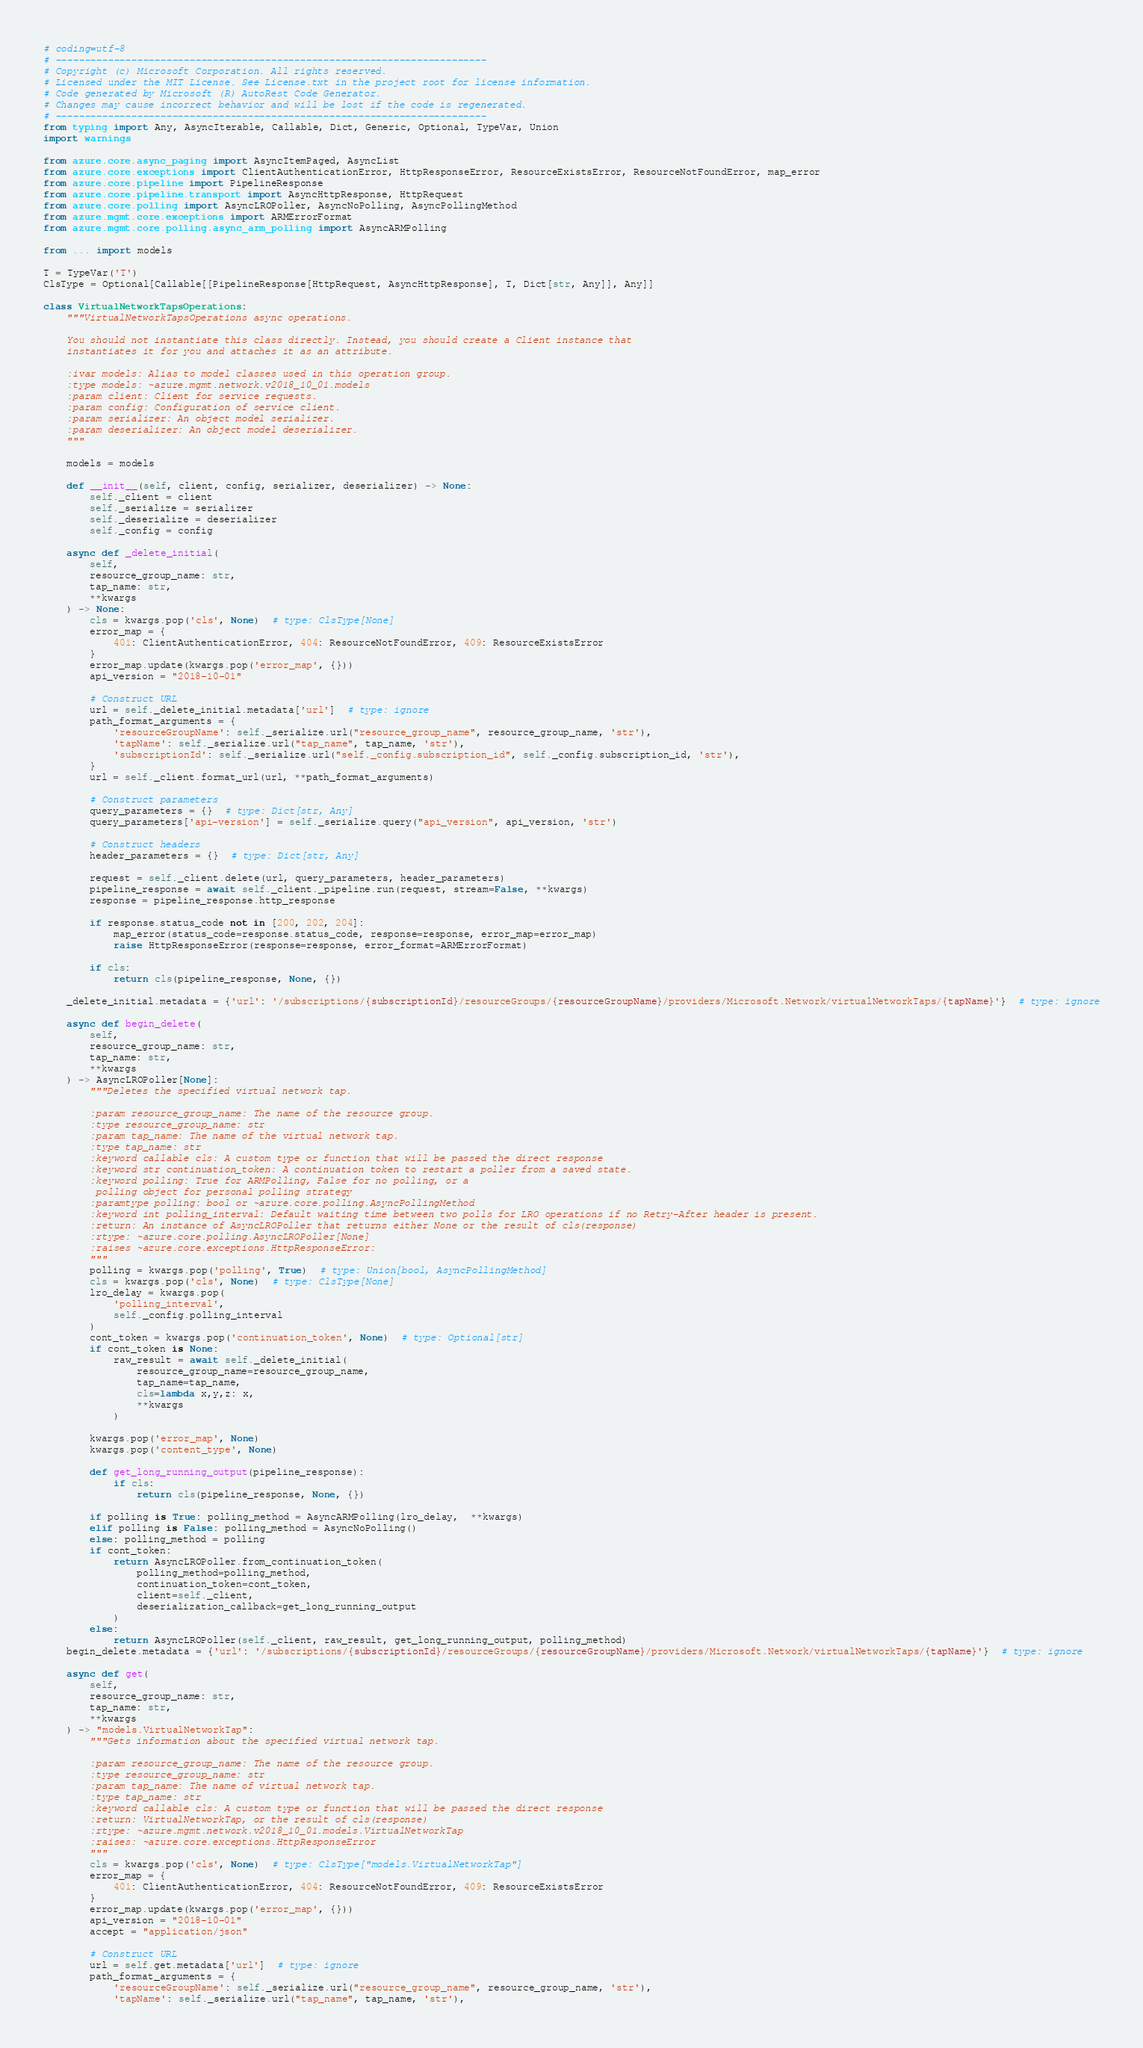Convert code to text. <code><loc_0><loc_0><loc_500><loc_500><_Python_># coding=utf-8
# --------------------------------------------------------------------------
# Copyright (c) Microsoft Corporation. All rights reserved.
# Licensed under the MIT License. See License.txt in the project root for license information.
# Code generated by Microsoft (R) AutoRest Code Generator.
# Changes may cause incorrect behavior and will be lost if the code is regenerated.
# --------------------------------------------------------------------------
from typing import Any, AsyncIterable, Callable, Dict, Generic, Optional, TypeVar, Union
import warnings

from azure.core.async_paging import AsyncItemPaged, AsyncList
from azure.core.exceptions import ClientAuthenticationError, HttpResponseError, ResourceExistsError, ResourceNotFoundError, map_error
from azure.core.pipeline import PipelineResponse
from azure.core.pipeline.transport import AsyncHttpResponse, HttpRequest
from azure.core.polling import AsyncLROPoller, AsyncNoPolling, AsyncPollingMethod
from azure.mgmt.core.exceptions import ARMErrorFormat
from azure.mgmt.core.polling.async_arm_polling import AsyncARMPolling

from ... import models

T = TypeVar('T')
ClsType = Optional[Callable[[PipelineResponse[HttpRequest, AsyncHttpResponse], T, Dict[str, Any]], Any]]

class VirtualNetworkTapsOperations:
    """VirtualNetworkTapsOperations async operations.

    You should not instantiate this class directly. Instead, you should create a Client instance that
    instantiates it for you and attaches it as an attribute.

    :ivar models: Alias to model classes used in this operation group.
    :type models: ~azure.mgmt.network.v2018_10_01.models
    :param client: Client for service requests.
    :param config: Configuration of service client.
    :param serializer: An object model serializer.
    :param deserializer: An object model deserializer.
    """

    models = models

    def __init__(self, client, config, serializer, deserializer) -> None:
        self._client = client
        self._serialize = serializer
        self._deserialize = deserializer
        self._config = config

    async def _delete_initial(
        self,
        resource_group_name: str,
        tap_name: str,
        **kwargs
    ) -> None:
        cls = kwargs.pop('cls', None)  # type: ClsType[None]
        error_map = {
            401: ClientAuthenticationError, 404: ResourceNotFoundError, 409: ResourceExistsError
        }
        error_map.update(kwargs.pop('error_map', {}))
        api_version = "2018-10-01"

        # Construct URL
        url = self._delete_initial.metadata['url']  # type: ignore
        path_format_arguments = {
            'resourceGroupName': self._serialize.url("resource_group_name", resource_group_name, 'str'),
            'tapName': self._serialize.url("tap_name", tap_name, 'str'),
            'subscriptionId': self._serialize.url("self._config.subscription_id", self._config.subscription_id, 'str'),
        }
        url = self._client.format_url(url, **path_format_arguments)

        # Construct parameters
        query_parameters = {}  # type: Dict[str, Any]
        query_parameters['api-version'] = self._serialize.query("api_version", api_version, 'str')

        # Construct headers
        header_parameters = {}  # type: Dict[str, Any]

        request = self._client.delete(url, query_parameters, header_parameters)
        pipeline_response = await self._client._pipeline.run(request, stream=False, **kwargs)
        response = pipeline_response.http_response

        if response.status_code not in [200, 202, 204]:
            map_error(status_code=response.status_code, response=response, error_map=error_map)
            raise HttpResponseError(response=response, error_format=ARMErrorFormat)

        if cls:
            return cls(pipeline_response, None, {})

    _delete_initial.metadata = {'url': '/subscriptions/{subscriptionId}/resourceGroups/{resourceGroupName}/providers/Microsoft.Network/virtualNetworkTaps/{tapName}'}  # type: ignore

    async def begin_delete(
        self,
        resource_group_name: str,
        tap_name: str,
        **kwargs
    ) -> AsyncLROPoller[None]:
        """Deletes the specified virtual network tap.

        :param resource_group_name: The name of the resource group.
        :type resource_group_name: str
        :param tap_name: The name of the virtual network tap.
        :type tap_name: str
        :keyword callable cls: A custom type or function that will be passed the direct response
        :keyword str continuation_token: A continuation token to restart a poller from a saved state.
        :keyword polling: True for ARMPolling, False for no polling, or a
         polling object for personal polling strategy
        :paramtype polling: bool or ~azure.core.polling.AsyncPollingMethod
        :keyword int polling_interval: Default waiting time between two polls for LRO operations if no Retry-After header is present.
        :return: An instance of AsyncLROPoller that returns either None or the result of cls(response)
        :rtype: ~azure.core.polling.AsyncLROPoller[None]
        :raises ~azure.core.exceptions.HttpResponseError:
        """
        polling = kwargs.pop('polling', True)  # type: Union[bool, AsyncPollingMethod]
        cls = kwargs.pop('cls', None)  # type: ClsType[None]
        lro_delay = kwargs.pop(
            'polling_interval',
            self._config.polling_interval
        )
        cont_token = kwargs.pop('continuation_token', None)  # type: Optional[str]
        if cont_token is None:
            raw_result = await self._delete_initial(
                resource_group_name=resource_group_name,
                tap_name=tap_name,
                cls=lambda x,y,z: x,
                **kwargs
            )

        kwargs.pop('error_map', None)
        kwargs.pop('content_type', None)

        def get_long_running_output(pipeline_response):
            if cls:
                return cls(pipeline_response, None, {})

        if polling is True: polling_method = AsyncARMPolling(lro_delay,  **kwargs)
        elif polling is False: polling_method = AsyncNoPolling()
        else: polling_method = polling
        if cont_token:
            return AsyncLROPoller.from_continuation_token(
                polling_method=polling_method,
                continuation_token=cont_token,
                client=self._client,
                deserialization_callback=get_long_running_output
            )
        else:
            return AsyncLROPoller(self._client, raw_result, get_long_running_output, polling_method)
    begin_delete.metadata = {'url': '/subscriptions/{subscriptionId}/resourceGroups/{resourceGroupName}/providers/Microsoft.Network/virtualNetworkTaps/{tapName}'}  # type: ignore

    async def get(
        self,
        resource_group_name: str,
        tap_name: str,
        **kwargs
    ) -> "models.VirtualNetworkTap":
        """Gets information about the specified virtual network tap.

        :param resource_group_name: The name of the resource group.
        :type resource_group_name: str
        :param tap_name: The name of virtual network tap.
        :type tap_name: str
        :keyword callable cls: A custom type or function that will be passed the direct response
        :return: VirtualNetworkTap, or the result of cls(response)
        :rtype: ~azure.mgmt.network.v2018_10_01.models.VirtualNetworkTap
        :raises: ~azure.core.exceptions.HttpResponseError
        """
        cls = kwargs.pop('cls', None)  # type: ClsType["models.VirtualNetworkTap"]
        error_map = {
            401: ClientAuthenticationError, 404: ResourceNotFoundError, 409: ResourceExistsError
        }
        error_map.update(kwargs.pop('error_map', {}))
        api_version = "2018-10-01"
        accept = "application/json"

        # Construct URL
        url = self.get.metadata['url']  # type: ignore
        path_format_arguments = {
            'resourceGroupName': self._serialize.url("resource_group_name", resource_group_name, 'str'),
            'tapName': self._serialize.url("tap_name", tap_name, 'str'),</code> 